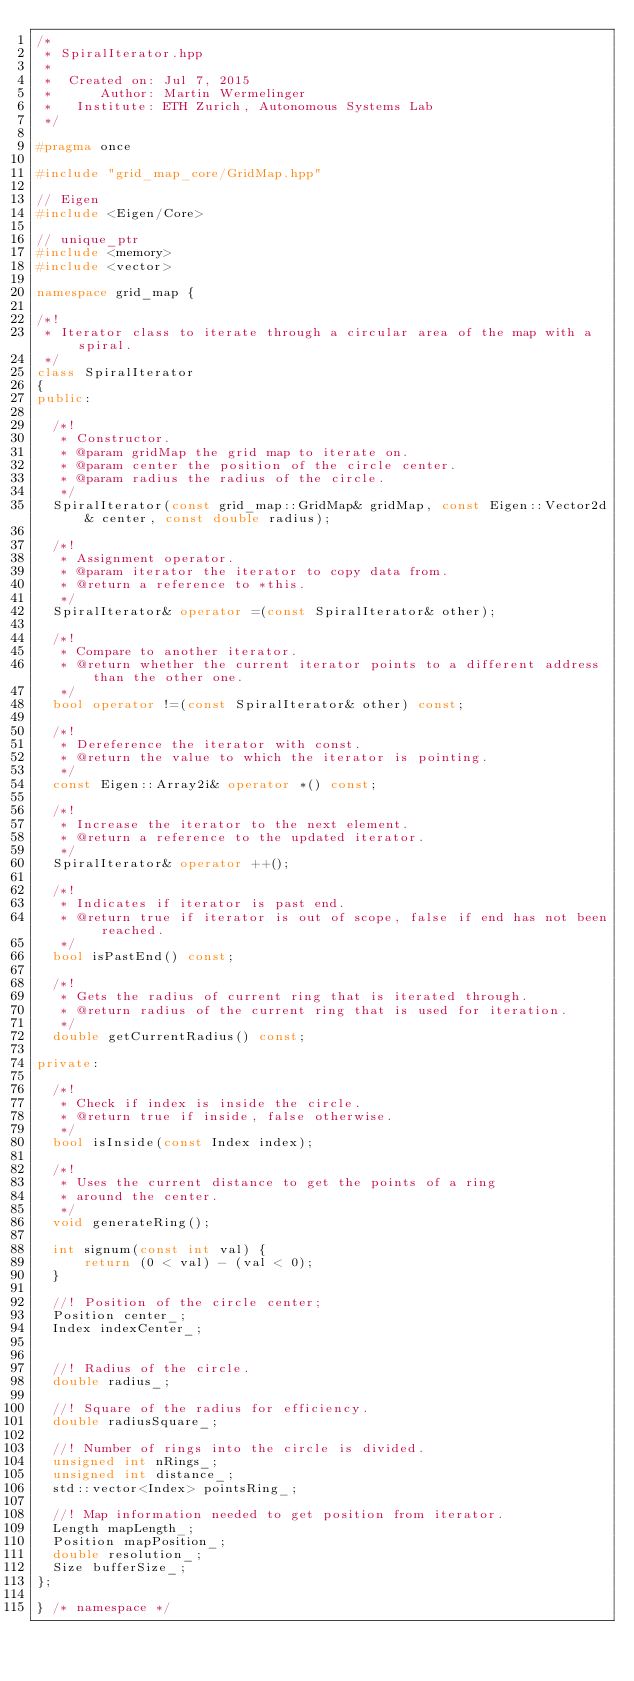Convert code to text. <code><loc_0><loc_0><loc_500><loc_500><_C++_>/*
 * SpiralIterator.hpp
 *
 *  Created on: Jul 7, 2015
 *      Author: Martin Wermelinger
 *   Institute: ETH Zurich, Autonomous Systems Lab
 */

#pragma once

#include "grid_map_core/GridMap.hpp"

// Eigen
#include <Eigen/Core>

// unique_ptr
#include <memory>
#include <vector>

namespace grid_map {

/*!
 * Iterator class to iterate through a circular area of the map with a spiral.
 */
class SpiralIterator
{
public:

  /*!
   * Constructor.
   * @param gridMap the grid map to iterate on.
   * @param center the position of the circle center.
   * @param radius the radius of the circle.
   */
  SpiralIterator(const grid_map::GridMap& gridMap, const Eigen::Vector2d& center, const double radius);

  /*!
   * Assignment operator.
   * @param iterator the iterator to copy data from.
   * @return a reference to *this.
   */
  SpiralIterator& operator =(const SpiralIterator& other);

  /*!
   * Compare to another iterator.
   * @return whether the current iterator points to a different address than the other one.
   */
  bool operator !=(const SpiralIterator& other) const;

  /*!
   * Dereference the iterator with const.
   * @return the value to which the iterator is pointing.
   */
  const Eigen::Array2i& operator *() const;

  /*!
   * Increase the iterator to the next element.
   * @return a reference to the updated iterator.
   */
  SpiralIterator& operator ++();

  /*!
   * Indicates if iterator is past end.
   * @return true if iterator is out of scope, false if end has not been reached.
   */
  bool isPastEnd() const;

  /*!
   * Gets the radius of current ring that is iterated through.
   * @return radius of the current ring that is used for iteration.
   */
  double getCurrentRadius() const;

private:

  /*!
   * Check if index is inside the circle.
   * @return true if inside, false otherwise.
   */
  bool isInside(const Index index);

  /*!
   * Uses the current distance to get the points of a ring
   * around the center.
   */
  void generateRing();

  int signum(const int val) {
      return (0 < val) - (val < 0);
  }

  //! Position of the circle center;
  Position center_;
  Index indexCenter_;


  //! Radius of the circle.
  double radius_;

  //! Square of the radius for efficiency.
  double radiusSquare_;

  //! Number of rings into the circle is divided.
  unsigned int nRings_;
  unsigned int distance_;
  std::vector<Index> pointsRing_;

  //! Map information needed to get position from iterator.
  Length mapLength_;
  Position mapPosition_;
  double resolution_;
  Size bufferSize_;
};

} /* namespace */
</code> 